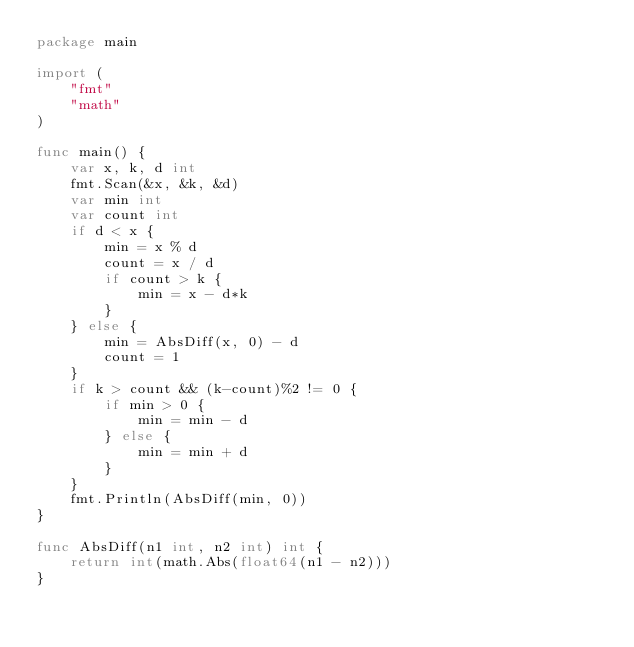<code> <loc_0><loc_0><loc_500><loc_500><_Go_>package main

import (
	"fmt"
	"math"
)

func main() {
	var x, k, d int
	fmt.Scan(&x, &k, &d)
	var min int
	var count int
	if d < x {
		min = x % d
		count = x / d
		if count > k {
			min = x - d*k
		}
	} else {
		min = AbsDiff(x, 0) - d
		count = 1
	}
	if k > count && (k-count)%2 != 0 {
		if min > 0 {
			min = min - d
		} else {
			min = min + d
		}
	}
	fmt.Println(AbsDiff(min, 0))
}

func AbsDiff(n1 int, n2 int) int {
	return int(math.Abs(float64(n1 - n2)))
}
</code> 